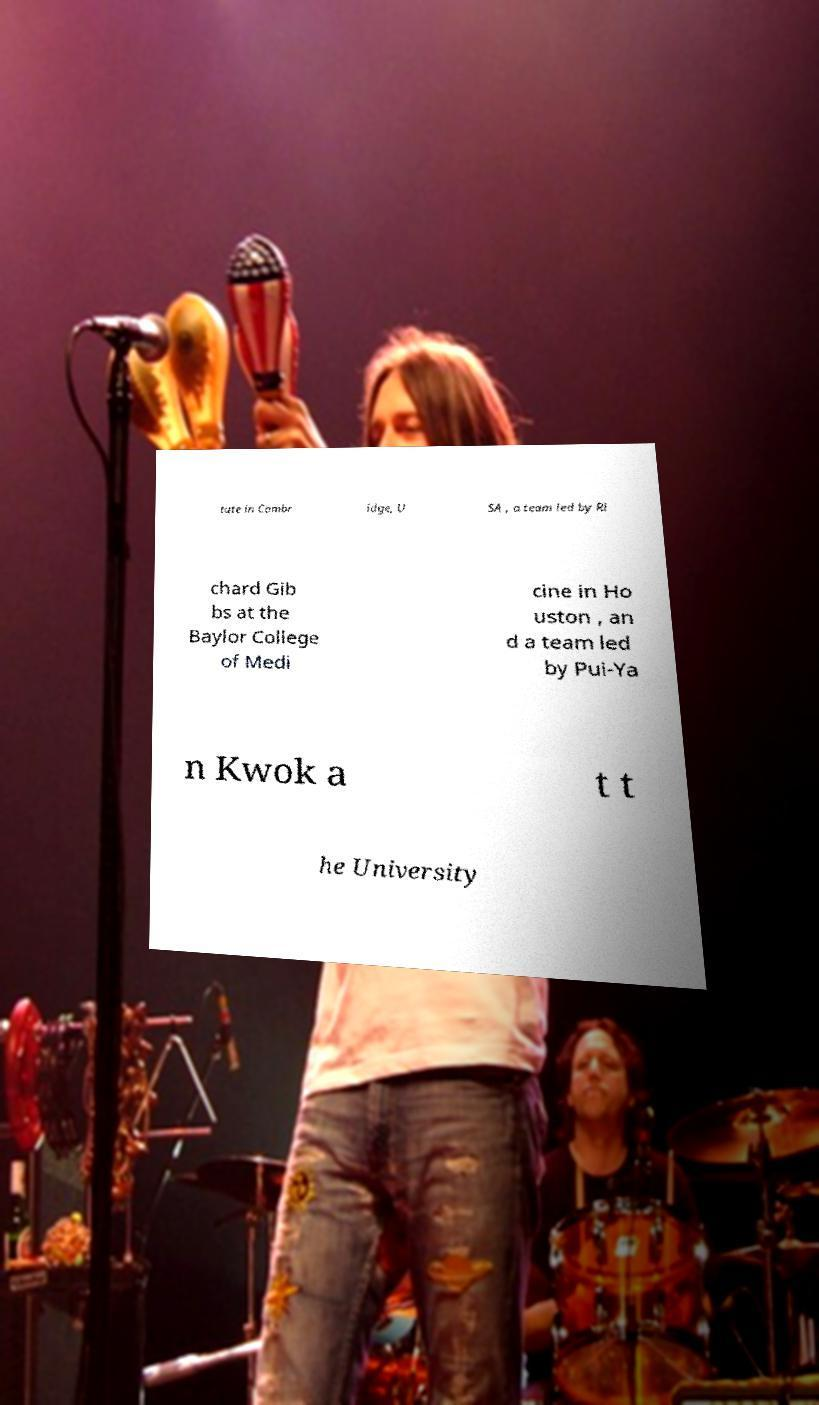I need the written content from this picture converted into text. Can you do that? tute in Cambr idge, U SA , a team led by Ri chard Gib bs at the Baylor College of Medi cine in Ho uston , an d a team led by Pui-Ya n Kwok a t t he University 